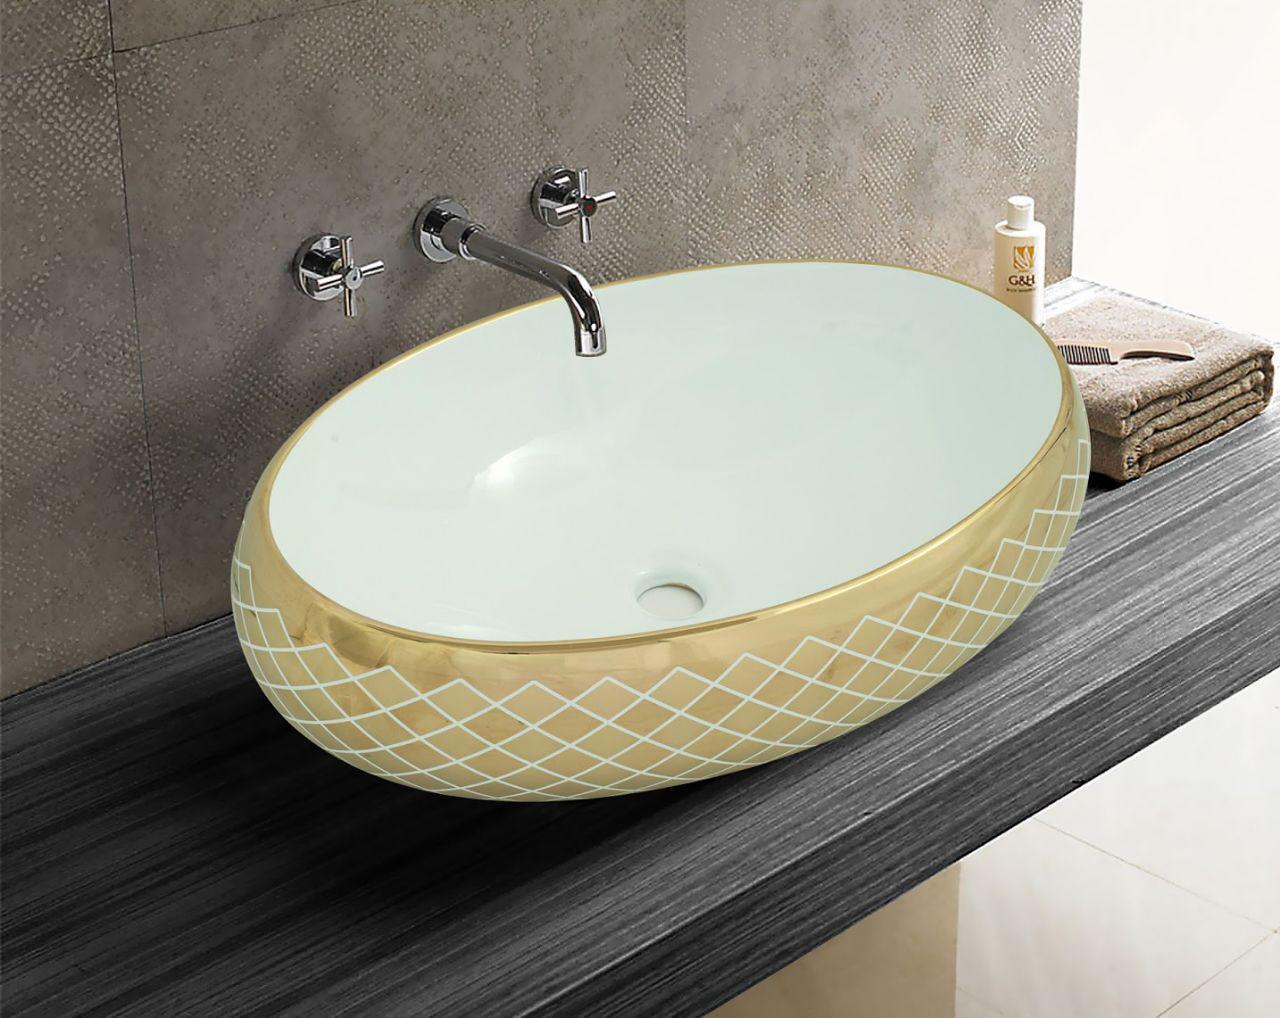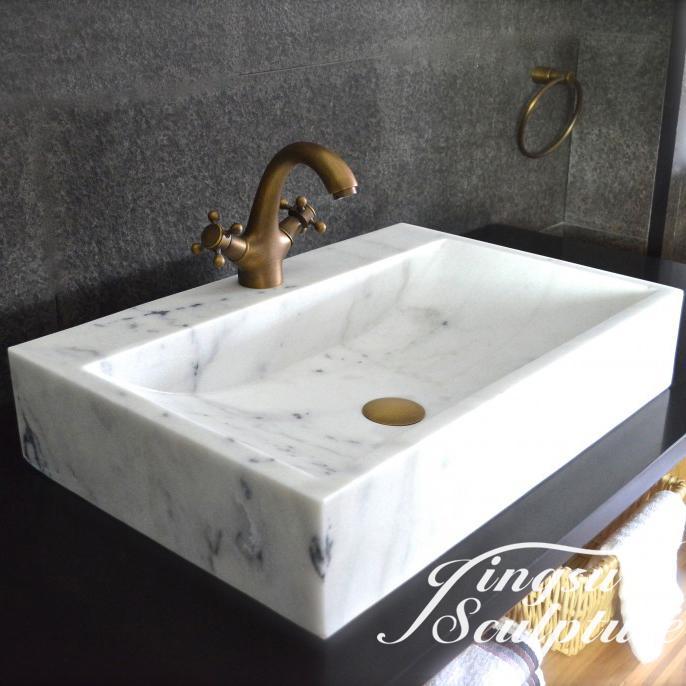The first image is the image on the left, the second image is the image on the right. Analyze the images presented: Is the assertion "Greenery can be seen past the sink on the left." valid? Answer yes or no. No. 